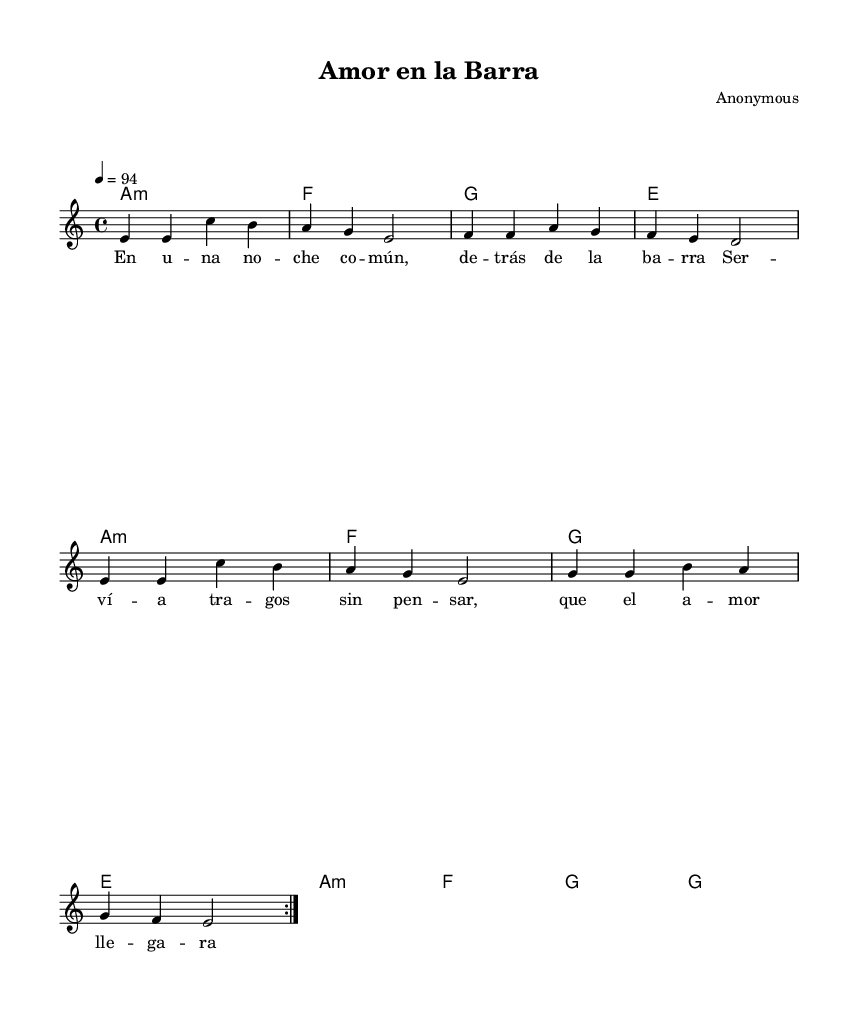What is the time signature of this music? The time signature is indicated as 4/4, which means there are four beats per measure and a quarter note gets one beat.
Answer: 4/4 What key is this music written in? The key signature is A minor, as indicated by the key signature at the beginning of the music, which has no sharps or flats.
Answer: A minor What is the tempo marking for this piece? The tempo is indicated as 4 = 94, which means there are 94 beats per minute when played at a quarter note speed.
Answer: 94 How many times is the verse repeated? The music specifies a volta repeat for the verse, meaning the first section of the verse is played twice.
Answer: 2 What type of musical piece is this? This music is categorized under Bachata, which is a style of Latin music known for its romantic themes and danceable rhythms.
Answer: Bachata What are the main themes of the lyrics in this song? The lyrics focus on unexpected love found in a communal setting, particularly at a bar, emphasizing how love can be surprising and spontaneous.
Answer: Unexpected love What is the first line of the chorus? The first line of the chorus is "A mor en la ba rra," which expresses the central theme of love found in a bar.
Answer: A mor en la ba rra 